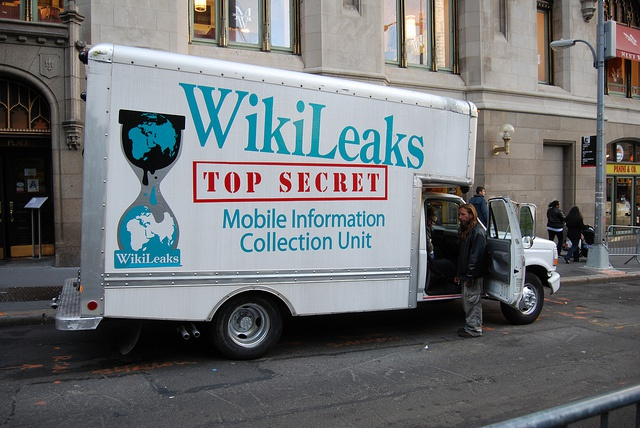Describe the objects in this image and their specific colors. I can see truck in black, lightgray, and darkgray tones, people in black, gray, and maroon tones, people in black, gray, and navy tones, people in black, gray, navy, and darkgreen tones, and people in black and gray tones in this image. 